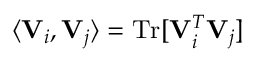<formula> <loc_0><loc_0><loc_500><loc_500>\langle { V } _ { i } , { V } _ { j } \rangle = T r [ { V } _ { i } ^ { T } { V } _ { j } ]</formula> 